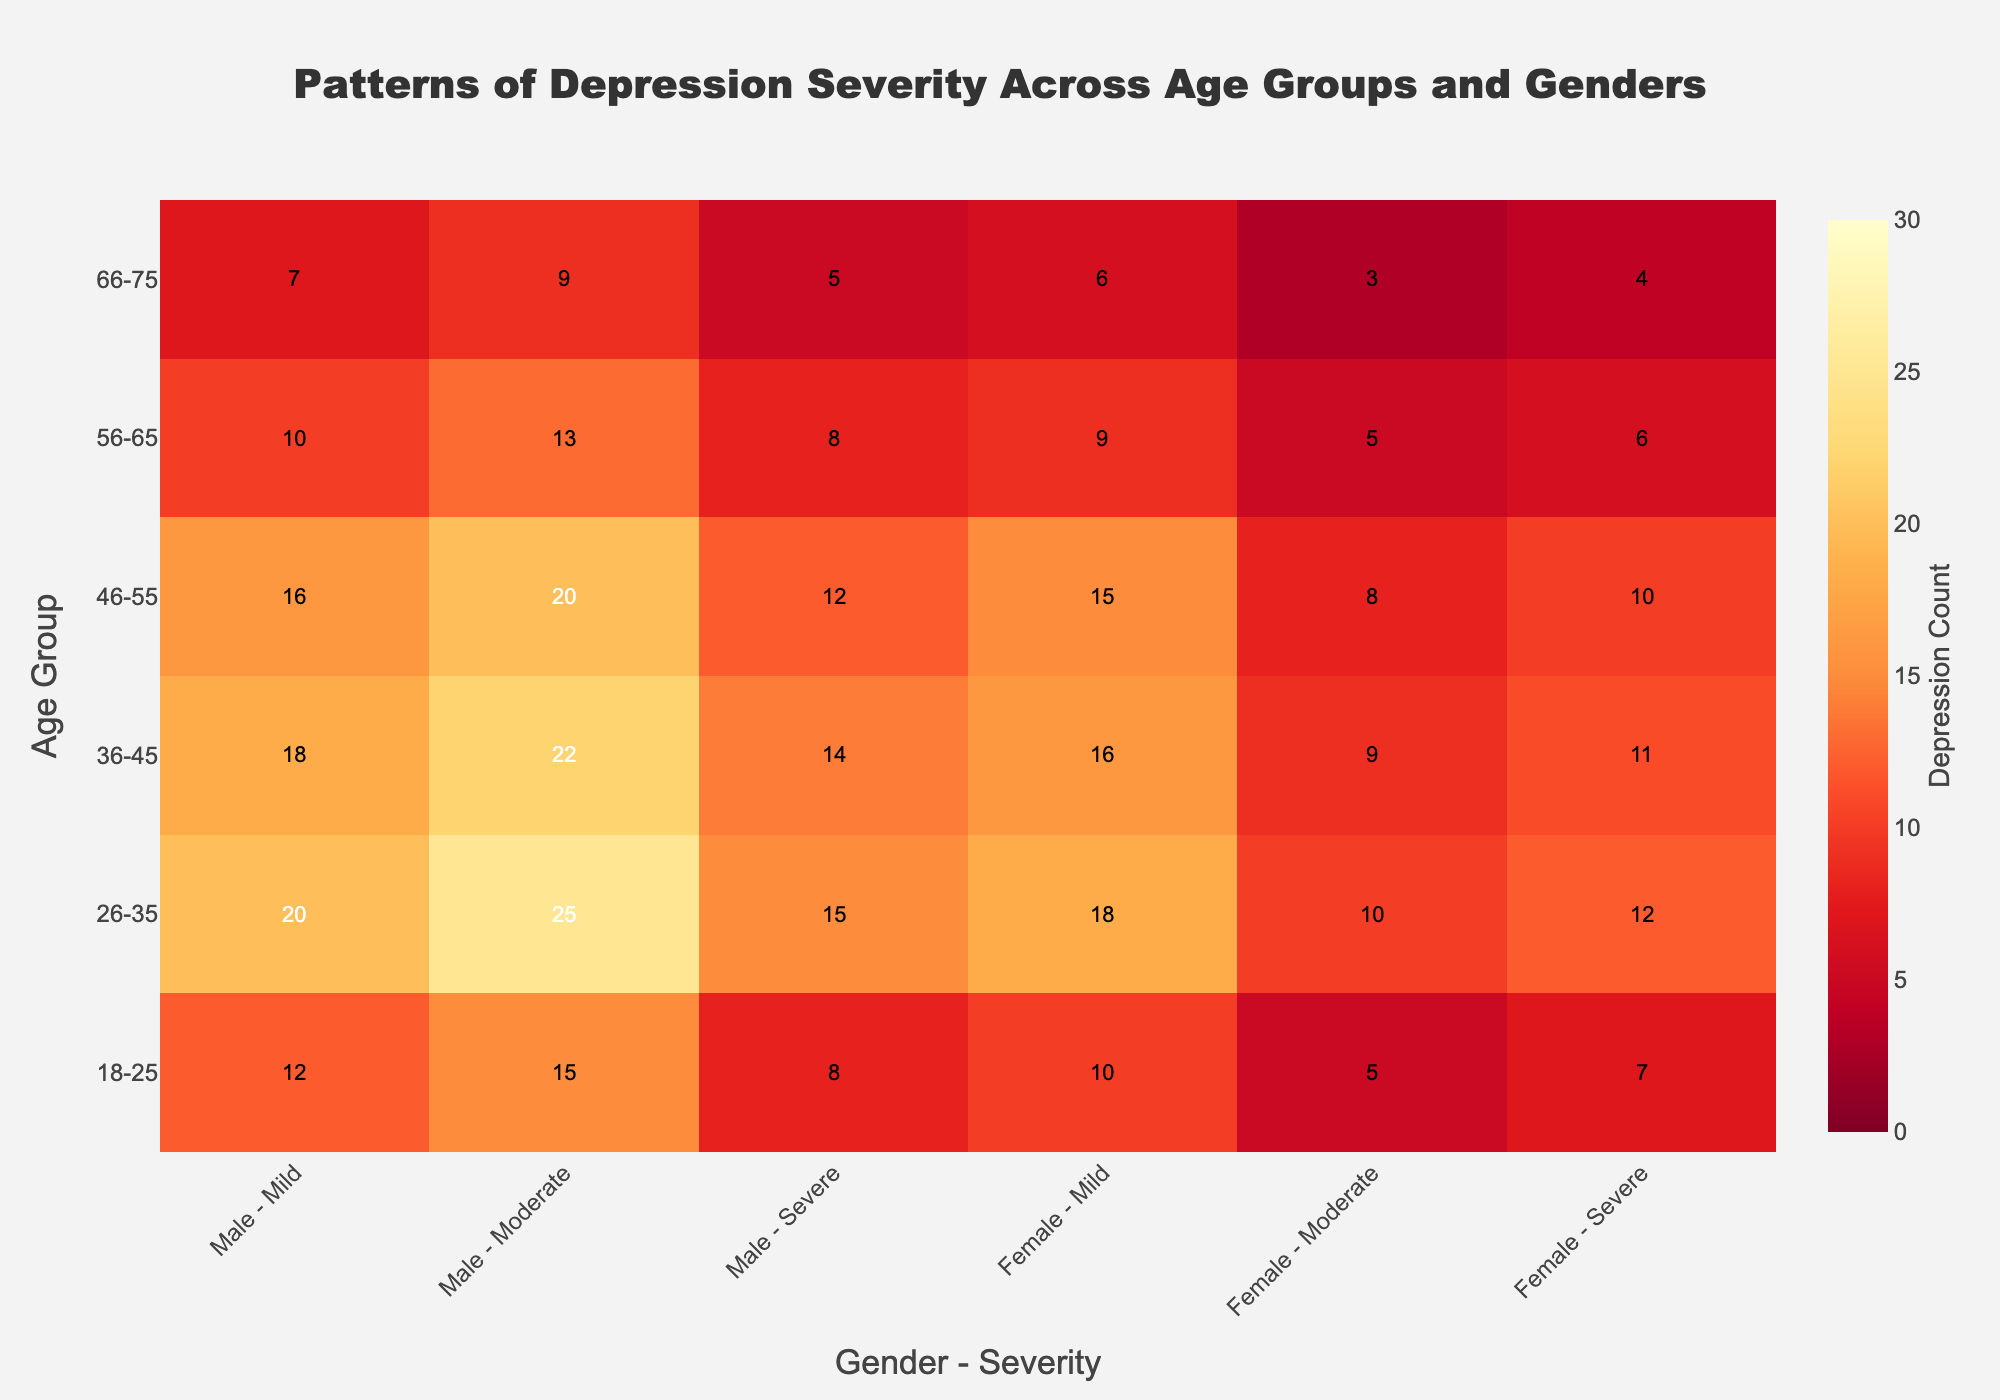What's the title of the heatmap? The title of the heatmap is usually displayed prominently at the top center of the figure. Here, it reads "Patterns of Depression Severity Across Age Groups and Genders".
Answer: Patterns of Depression Severity Across Age Groups and Genders What age group has the highest count of moderate depression for females? Find the "Male - Moderate" and "Female - Moderate" columns, then look down the "Female - Moderate" column to identify the largest value. The highest count for moderate depression in females is found in the 26-35 age group with a count of 18.
Answer: 26-35 Which gender and depression severity combination shows the lowest count in the 66-75 age group? Look at the row for the 66-75 age group and compare the values for all gender and severity combinations. The lowest count is "Male - Severe" with a count of 3.
Answer: Male - Severe How does the number of males with mild depression in the 46-55 age group compare to those in the 36-45 age group? Check the "Male - Mild" counts for the 46-55 and 36-45 age groups. The 46-55 age group has 16 cases, while the 36-45 age group has 18 cases. Comparing these, the count for the 46-55 group is 2 less than the 36-45 group.
Answer: 2 less Which age group and gender combination has the highest overall count of depression? Find the cell with the highest value in the entire heatmap. The highest number of depression cases is in the "Female - Mild" category for the 26-35 age group, with a count of 25.
Answer: Female - 26-35 What is the total count of severe depression for all age groups and both genders combined? Add up all the values in the "Male - Severe" and "Female - Severe" columns to get the total. The counts are 5 + 10 + 9 + 8 + 5 + 3 for males and 7 + 12 + 11 + 10 + 6 + 4 for females. Total: 50 + 50 = 50
Answer: 50 What is the average number of moderate depression cases for males across all age groups? Add up the counts of "Male - Moderate" across all age groups and then divide by the number of age groups. The counts are 8 + 15 + 14 + 12 + 8 + 5, summed to 62. Divide by the number of age groups (6), 62 / 6 ≈ 10.33.
Answer: 10.33 Is the count of mild depression for females higher in the 18-25 age group or the 26-35 age group? Compare the "Female - Mild" values for the 18-25 age group (15) and the 26-35 age group (25). 25 is greater than 15.
Answer: 26-35 What is the combined count of moderate depression for both genders in the 56-65 age group? Add the "Male - Moderate" and "Female - Moderate" counts in the 56-65 age group. Male count is 8 and female count is 9. So, 8 + 9 = 17.
Answer: 17 Which age group shows the most substantial difference between male and female counts for severe depression? Subtract the "Male - Severe" count from the "Female - Severe" count for each age group. The differences are 2 (18-25), 2 (26-35), 2 (36-45), 2 (46-55), 1 (56-65), and 1 (66-75). Thus, there is no substantial difference, and all disparities are very small.
Answer: No substantial difference 